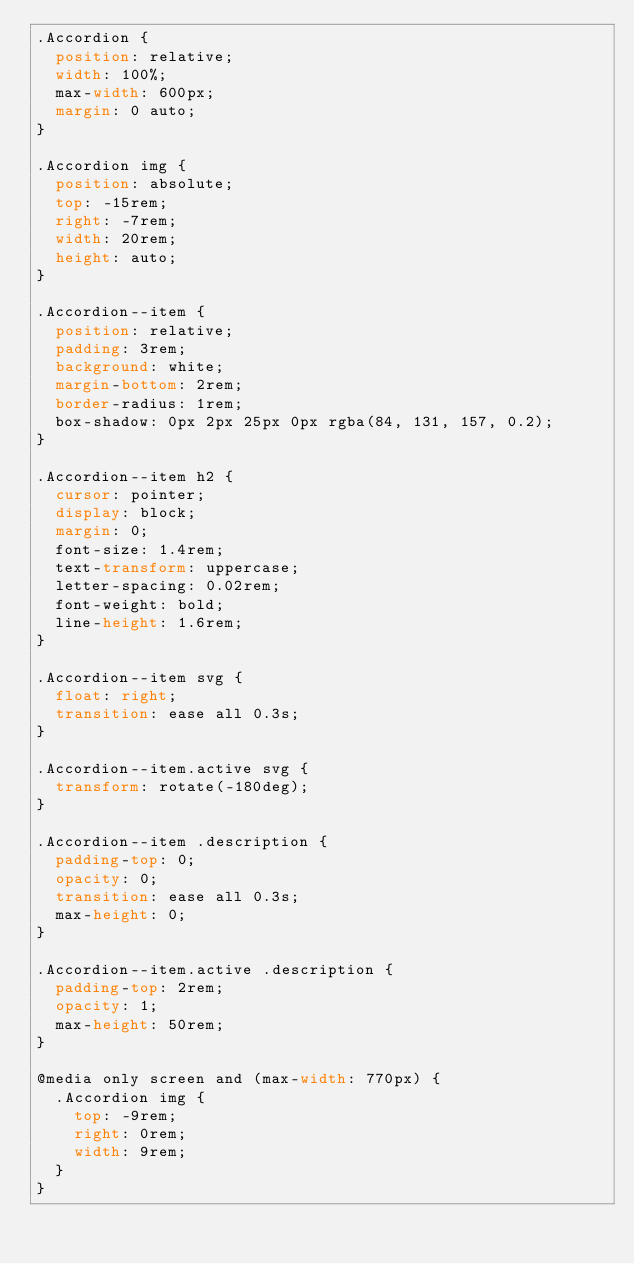Convert code to text. <code><loc_0><loc_0><loc_500><loc_500><_CSS_>.Accordion {
  position: relative;
  width: 100%;
  max-width: 600px;
  margin: 0 auto;
}

.Accordion img {
  position: absolute;
  top: -15rem;
  right: -7rem;
  width: 20rem;
  height: auto;
}

.Accordion--item {
  position: relative;
  padding: 3rem;
  background: white;
  margin-bottom: 2rem;
  border-radius: 1rem;
  box-shadow: 0px 2px 25px 0px rgba(84, 131, 157, 0.2);
}

.Accordion--item h2 {
  cursor: pointer;
  display: block;
  margin: 0;
  font-size: 1.4rem;
  text-transform: uppercase;
  letter-spacing: 0.02rem;
  font-weight: bold;
  line-height: 1.6rem;
}

.Accordion--item svg {
  float: right;
  transition: ease all 0.3s;
}

.Accordion--item.active svg {
  transform: rotate(-180deg);
}

.Accordion--item .description {
  padding-top: 0;
  opacity: 0;
  transition: ease all 0.3s;
  max-height: 0;
}

.Accordion--item.active .description {
  padding-top: 2rem;
  opacity: 1;
  max-height: 50rem;
}

@media only screen and (max-width: 770px) {
  .Accordion img {
    top: -9rem;
    right: 0rem;
    width: 9rem;
  }
}
</code> 